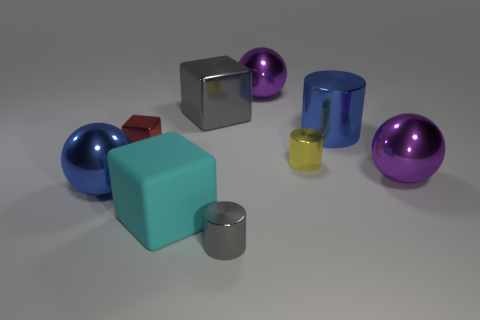What number of things are either tiny objects to the left of the tiny yellow metal object or blue metallic objects that are to the left of the large metallic cube?
Give a very brief answer. 3. What number of other objects are there of the same color as the large metallic cube?
Give a very brief answer. 1. There is a blue metal object on the left side of the big gray block; does it have the same shape as the tiny red metal object?
Give a very brief answer. No. Are there fewer large blue cylinders that are in front of the small metal cube than gray shiny objects?
Ensure brevity in your answer.  Yes. Are there any blocks that have the same material as the small gray cylinder?
Ensure brevity in your answer.  Yes. What material is the cyan block that is the same size as the gray shiny cube?
Provide a short and direct response. Rubber. Are there fewer small shiny things that are in front of the matte block than metallic spheres on the left side of the tiny yellow metal thing?
Provide a succinct answer. Yes. What is the shape of the tiny object that is both on the left side of the yellow cylinder and behind the cyan matte object?
Ensure brevity in your answer.  Cube. What number of gray objects have the same shape as the cyan rubber thing?
Your answer should be very brief. 1. There is a blue sphere that is made of the same material as the gray cube; what size is it?
Your response must be concise. Large. 